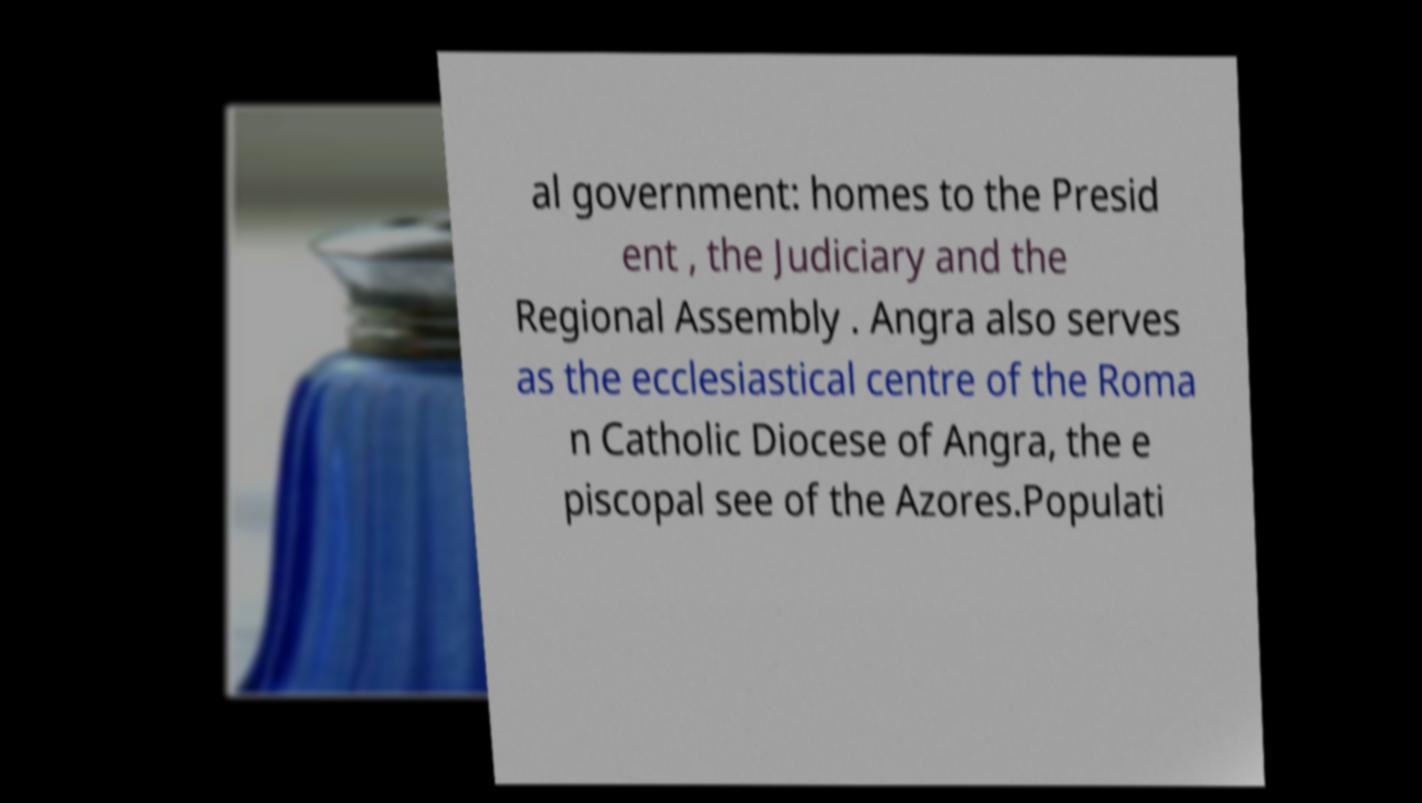What messages or text are displayed in this image? I need them in a readable, typed format. al government: homes to the Presid ent , the Judiciary and the Regional Assembly . Angra also serves as the ecclesiastical centre of the Roma n Catholic Diocese of Angra, the e piscopal see of the Azores.Populati 